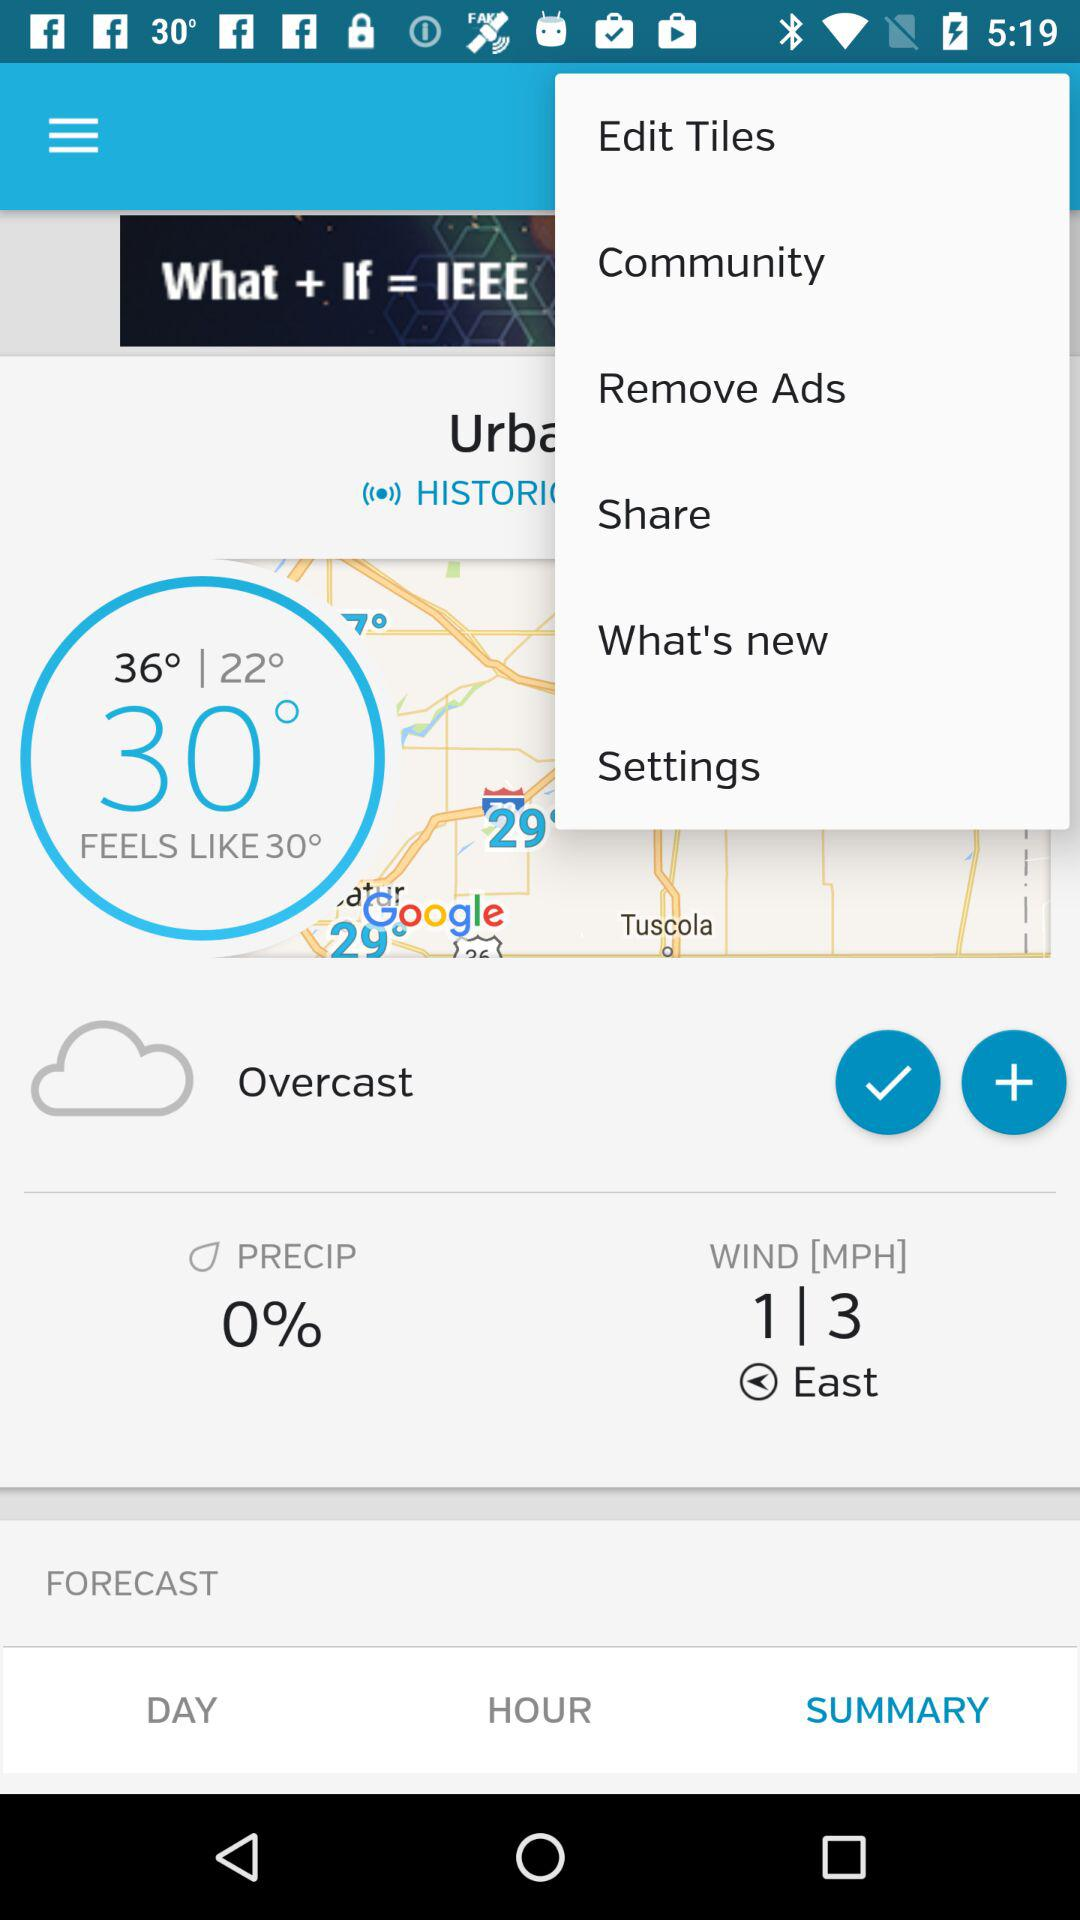What is the percentage of precipitation? The percentage of precipitation is 0. 